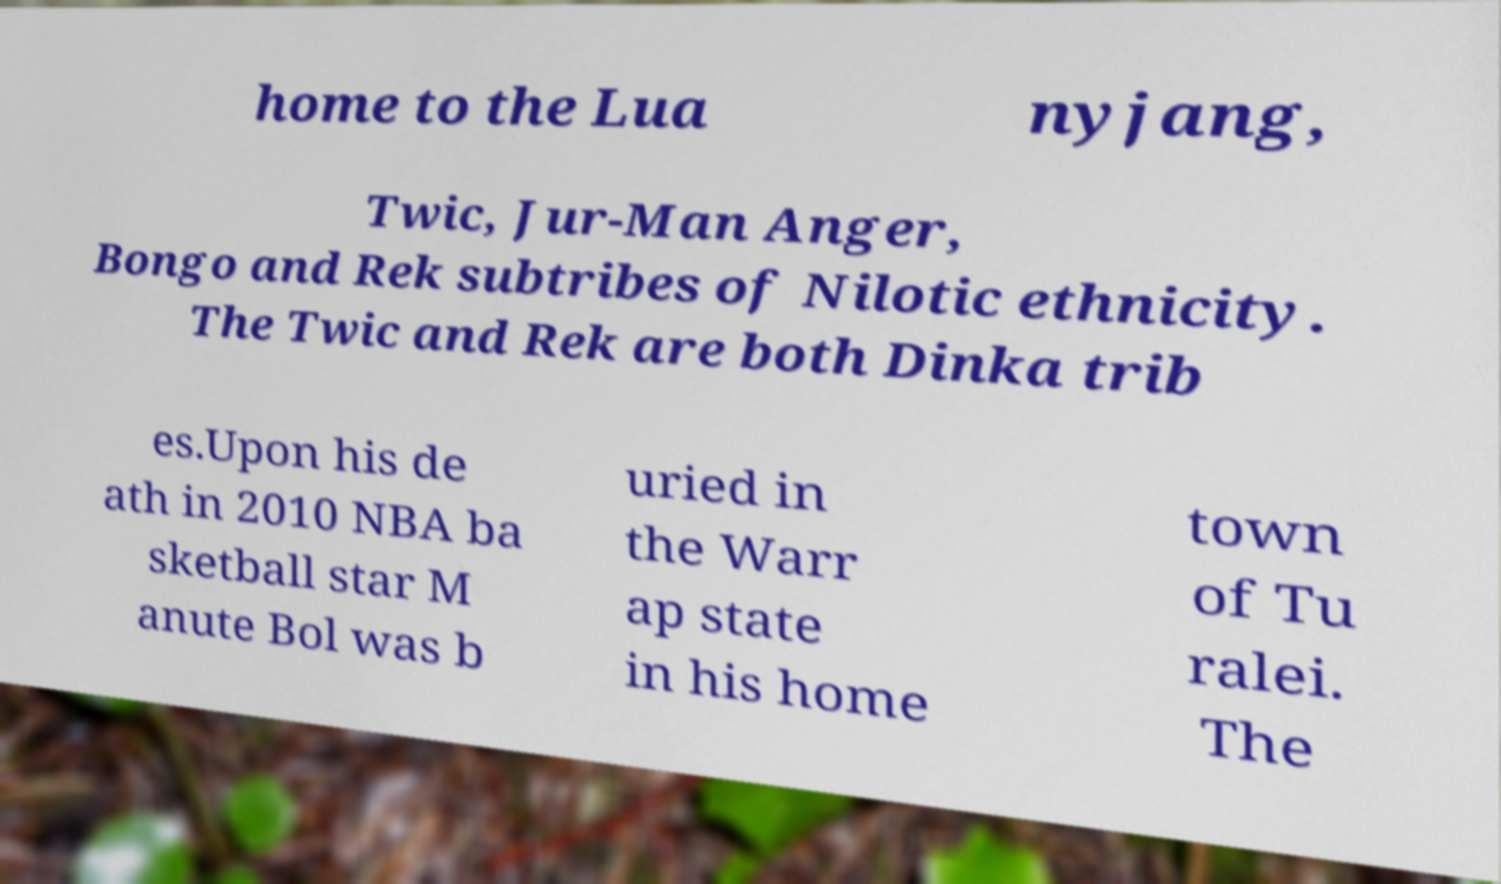For documentation purposes, I need the text within this image transcribed. Could you provide that? home to the Lua nyjang, Twic, Jur-Man Anger, Bongo and Rek subtribes of Nilotic ethnicity. The Twic and Rek are both Dinka trib es.Upon his de ath in 2010 NBA ba sketball star M anute Bol was b uried in the Warr ap state in his home town of Tu ralei. The 